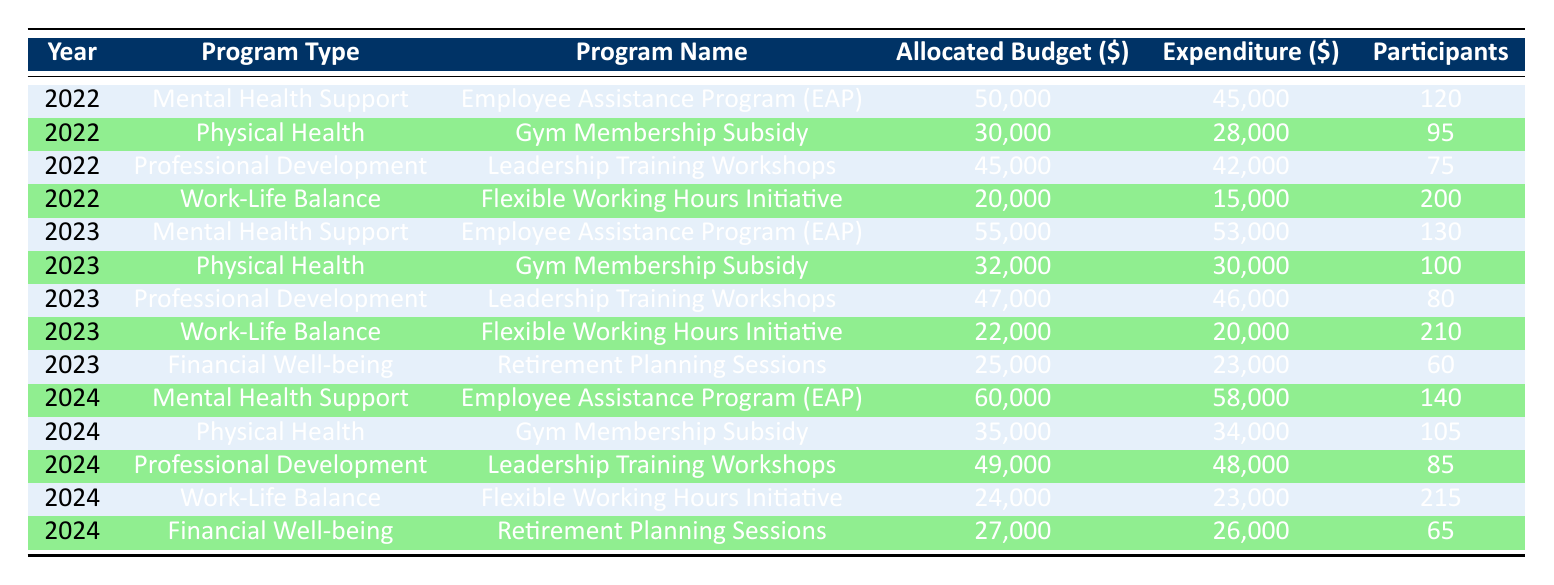What was the allocated budget for the Employee Assistance Program in 2022022? The table shows that the allocated budget for the Employee Assistance Program in 2022 was $50,000 under the Mental Health Support category.
Answer: 50000 How many participants engaged in the Flexible Working Hours Initiative in 2023? Referring to the table, the Flexible Working Hours Initiative in 2023 had 210 participants, as listed in the Work-Life Balance section.
Answer: 210 What is the total expenditure across all programs in 2022? To find the total expenditure for 2022, we need to add the expenditures for all programs: 45000 (EAP) + 28000 (Gym Subsidy) + 42000 (Leadership Training) + 15000 (Flexible Working) = 130000.
Answer: 130000 Was the allocated budget for the Gym Membership Subsidy in 2024 greater than the expenditure for the same program? According to the table, the allocated budget for the Gym Membership Subsidy in 2024 was $35,000 and the expenditure was $34,000. Since $35,000 is greater than $34,000, the statement is true.
Answer: Yes Which program had the highest expenditure in 2023? By reviewing the expenditures in 2023, we find: EAP $53,000, Gym Subsidy $30,000, Leadership Training $46,000, Flexible Working $20,000, and Retirement Planning $23,000. The highest expenditure is for the Employee Assistance Program at $53,000.
Answer: Employee Assistance Program What was the increase in allocated budget for the Employee Assistance Program from 2022 to 2024? The allocated budget for the Employee Assistance Program was $50,000 in 2022 and $60,000 in 2024. The increase is calculated as $60,000 - $50,000 = $10,000.
Answer: 10000 What percentage of participants attended the Leadership Training Workshops in 2023 compared to 2022? In 2022, 75 participants attended the Leadership Training Workshops, and in 2023, 80 participants attended. The percentage increase is ((80 - 75) / 75) * 100 = 6.67%.
Answer: 6.67% Is the expenditure for Financial Well-being programs in 2024 lower than that in the previous year (2023)? The expenditure for the Financial Well-being program in 2024 is $26,000, while in 2023 it was $23,000. Since $26,000 is greater than $23,000, the statement is false.
Answer: No 